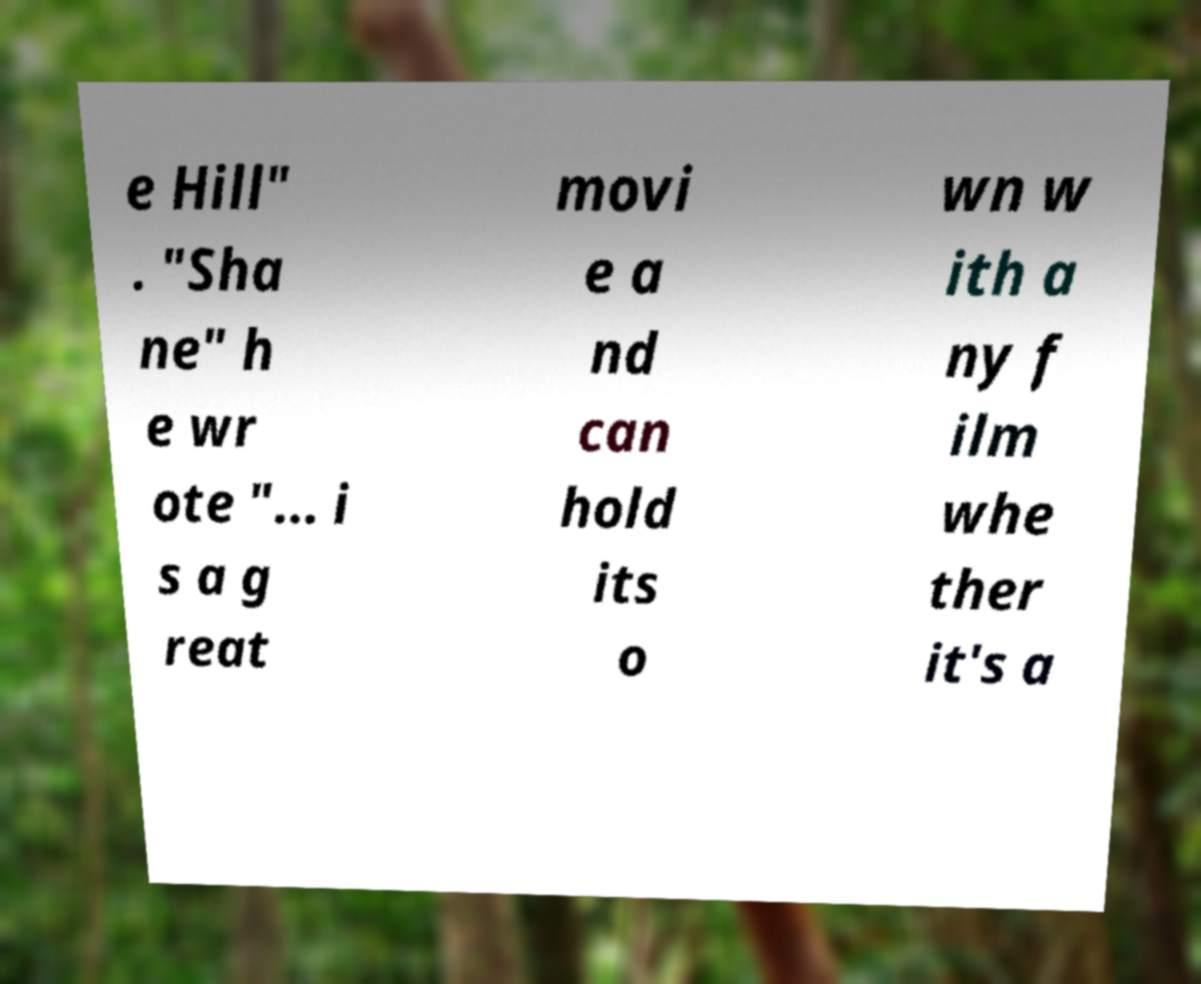There's text embedded in this image that I need extracted. Can you transcribe it verbatim? e Hill" . "Sha ne" h e wr ote "... i s a g reat movi e a nd can hold its o wn w ith a ny f ilm whe ther it's a 